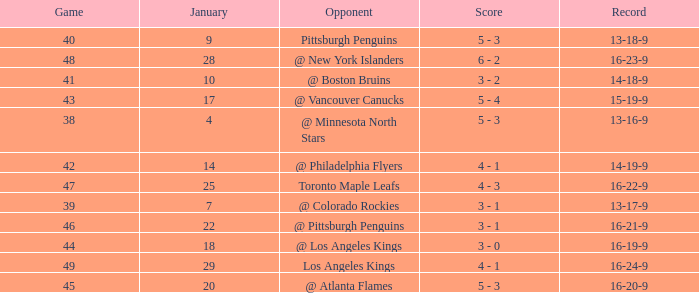What was the record after the game before Jan 7? 13-16-9. 